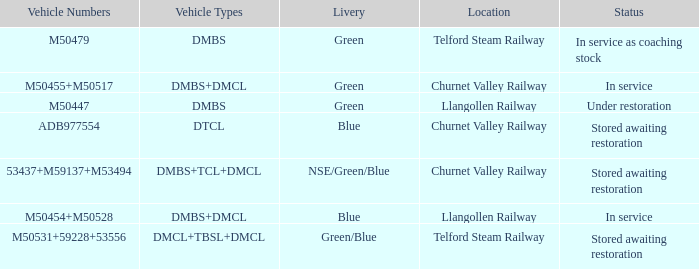What livery has a status of in service as coaching stock? Green. 